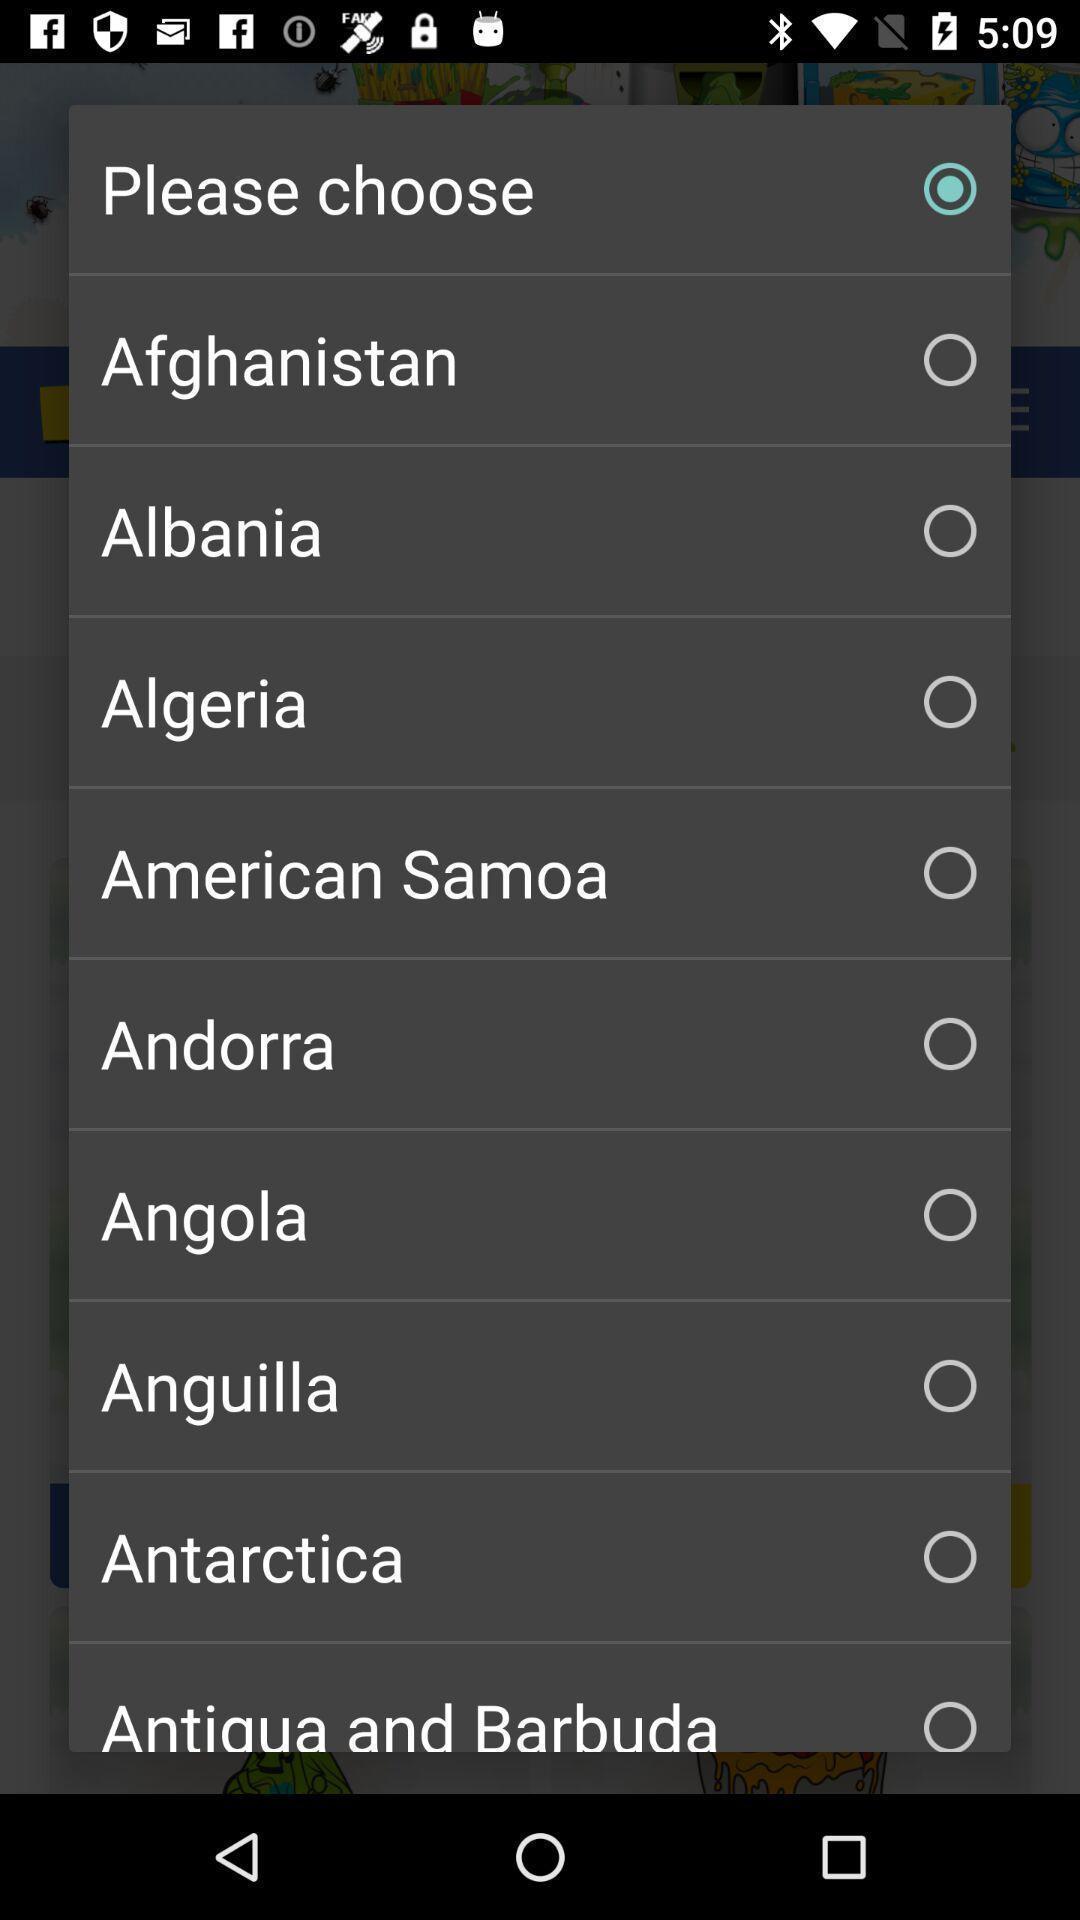Explain what's happening in this screen capture. Popup to choose from list of places in the app. 